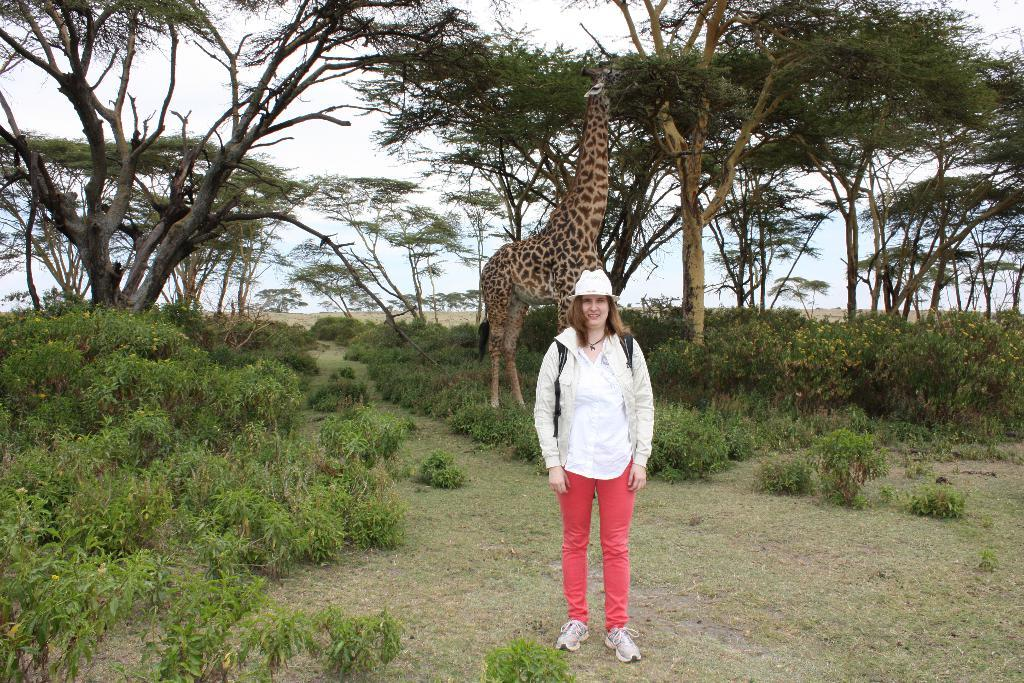What is the main subject of the image? There is a woman standing in the image. What is the woman wearing? The woman is wearing a bag. What animal can be seen behind the woman? There is a giraffe behind the woman. What type of vegetation is present in the image? There are plants and trees in the image. What can be seen in the background of the image? The sky is visible in the background of the image. What type of disease is affecting the alley in the image? There is no alley present in the image, and therefore no disease can be affecting it. 